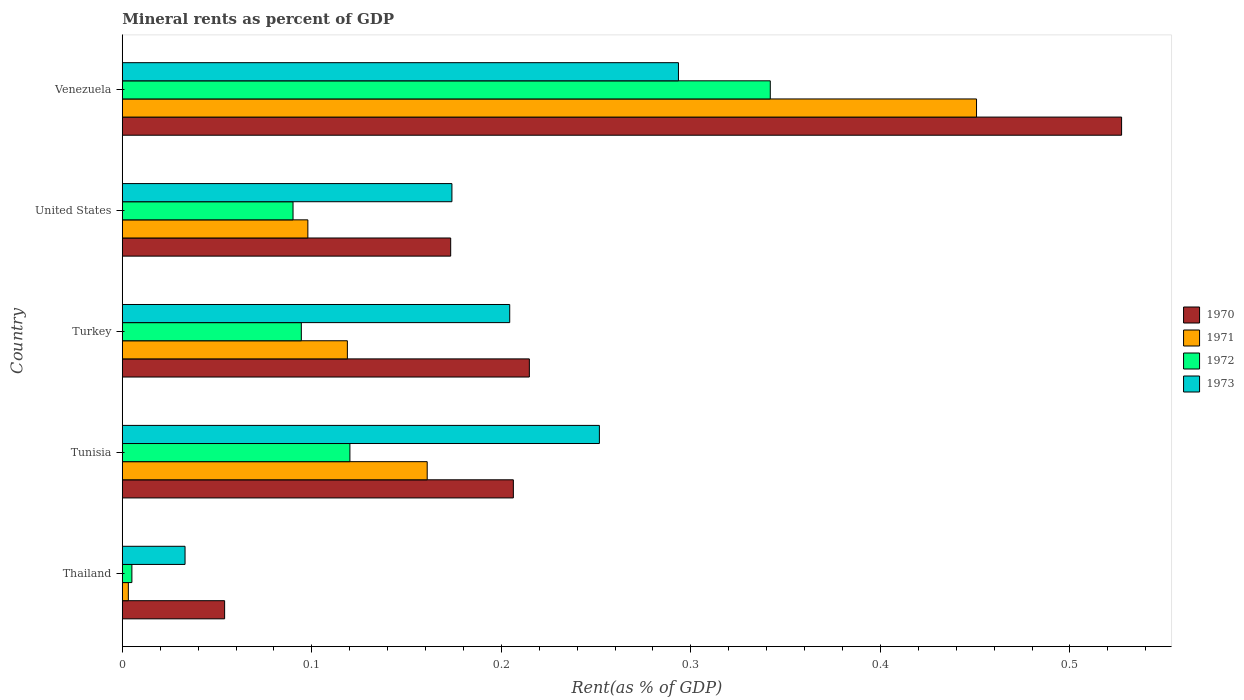How many different coloured bars are there?
Your response must be concise. 4. How many groups of bars are there?
Offer a very short reply. 5. Are the number of bars on each tick of the Y-axis equal?
Make the answer very short. Yes. How many bars are there on the 3rd tick from the top?
Your answer should be very brief. 4. How many bars are there on the 1st tick from the bottom?
Give a very brief answer. 4. What is the label of the 5th group of bars from the top?
Provide a short and direct response. Thailand. In how many cases, is the number of bars for a given country not equal to the number of legend labels?
Provide a succinct answer. 0. What is the mineral rent in 1971 in Tunisia?
Provide a short and direct response. 0.16. Across all countries, what is the maximum mineral rent in 1971?
Your answer should be very brief. 0.45. Across all countries, what is the minimum mineral rent in 1972?
Keep it short and to the point. 0.01. In which country was the mineral rent in 1972 maximum?
Offer a terse response. Venezuela. In which country was the mineral rent in 1972 minimum?
Offer a very short reply. Thailand. What is the total mineral rent in 1972 in the graph?
Keep it short and to the point. 0.65. What is the difference between the mineral rent in 1971 in Turkey and that in Venezuela?
Ensure brevity in your answer.  -0.33. What is the difference between the mineral rent in 1973 in Venezuela and the mineral rent in 1970 in Turkey?
Your answer should be very brief. 0.08. What is the average mineral rent in 1970 per country?
Keep it short and to the point. 0.24. What is the difference between the mineral rent in 1973 and mineral rent in 1970 in Thailand?
Give a very brief answer. -0.02. What is the ratio of the mineral rent in 1971 in United States to that in Venezuela?
Give a very brief answer. 0.22. Is the mineral rent in 1970 in United States less than that in Venezuela?
Provide a short and direct response. Yes. What is the difference between the highest and the second highest mineral rent in 1971?
Give a very brief answer. 0.29. What is the difference between the highest and the lowest mineral rent in 1971?
Make the answer very short. 0.45. In how many countries, is the mineral rent in 1970 greater than the average mineral rent in 1970 taken over all countries?
Your answer should be very brief. 1. What does the 4th bar from the bottom in Tunisia represents?
Make the answer very short. 1973. How many bars are there?
Offer a terse response. 20. How many countries are there in the graph?
Keep it short and to the point. 5. What is the difference between two consecutive major ticks on the X-axis?
Ensure brevity in your answer.  0.1. Does the graph contain any zero values?
Ensure brevity in your answer.  No. How many legend labels are there?
Your response must be concise. 4. How are the legend labels stacked?
Your answer should be compact. Vertical. What is the title of the graph?
Offer a very short reply. Mineral rents as percent of GDP. What is the label or title of the X-axis?
Make the answer very short. Rent(as % of GDP). What is the label or title of the Y-axis?
Keep it short and to the point. Country. What is the Rent(as % of GDP) in 1970 in Thailand?
Your answer should be very brief. 0.05. What is the Rent(as % of GDP) of 1971 in Thailand?
Your response must be concise. 0. What is the Rent(as % of GDP) of 1972 in Thailand?
Your answer should be very brief. 0.01. What is the Rent(as % of GDP) in 1973 in Thailand?
Your answer should be compact. 0.03. What is the Rent(as % of GDP) of 1970 in Tunisia?
Ensure brevity in your answer.  0.21. What is the Rent(as % of GDP) of 1971 in Tunisia?
Offer a very short reply. 0.16. What is the Rent(as % of GDP) in 1972 in Tunisia?
Keep it short and to the point. 0.12. What is the Rent(as % of GDP) of 1973 in Tunisia?
Your answer should be very brief. 0.25. What is the Rent(as % of GDP) of 1970 in Turkey?
Your response must be concise. 0.21. What is the Rent(as % of GDP) of 1971 in Turkey?
Make the answer very short. 0.12. What is the Rent(as % of GDP) in 1972 in Turkey?
Keep it short and to the point. 0.09. What is the Rent(as % of GDP) in 1973 in Turkey?
Your answer should be very brief. 0.2. What is the Rent(as % of GDP) in 1970 in United States?
Ensure brevity in your answer.  0.17. What is the Rent(as % of GDP) in 1971 in United States?
Make the answer very short. 0.1. What is the Rent(as % of GDP) of 1972 in United States?
Your answer should be very brief. 0.09. What is the Rent(as % of GDP) in 1973 in United States?
Your answer should be very brief. 0.17. What is the Rent(as % of GDP) in 1970 in Venezuela?
Ensure brevity in your answer.  0.53. What is the Rent(as % of GDP) of 1971 in Venezuela?
Your response must be concise. 0.45. What is the Rent(as % of GDP) in 1972 in Venezuela?
Your answer should be very brief. 0.34. What is the Rent(as % of GDP) of 1973 in Venezuela?
Provide a short and direct response. 0.29. Across all countries, what is the maximum Rent(as % of GDP) in 1970?
Ensure brevity in your answer.  0.53. Across all countries, what is the maximum Rent(as % of GDP) of 1971?
Your answer should be very brief. 0.45. Across all countries, what is the maximum Rent(as % of GDP) of 1972?
Provide a succinct answer. 0.34. Across all countries, what is the maximum Rent(as % of GDP) in 1973?
Provide a short and direct response. 0.29. Across all countries, what is the minimum Rent(as % of GDP) in 1970?
Ensure brevity in your answer.  0.05. Across all countries, what is the minimum Rent(as % of GDP) in 1971?
Give a very brief answer. 0. Across all countries, what is the minimum Rent(as % of GDP) in 1972?
Provide a short and direct response. 0.01. Across all countries, what is the minimum Rent(as % of GDP) of 1973?
Make the answer very short. 0.03. What is the total Rent(as % of GDP) in 1970 in the graph?
Your response must be concise. 1.18. What is the total Rent(as % of GDP) of 1971 in the graph?
Your response must be concise. 0.83. What is the total Rent(as % of GDP) in 1972 in the graph?
Your answer should be compact. 0.65. What is the total Rent(as % of GDP) in 1973 in the graph?
Provide a short and direct response. 0.96. What is the difference between the Rent(as % of GDP) of 1970 in Thailand and that in Tunisia?
Ensure brevity in your answer.  -0.15. What is the difference between the Rent(as % of GDP) in 1971 in Thailand and that in Tunisia?
Your response must be concise. -0.16. What is the difference between the Rent(as % of GDP) of 1972 in Thailand and that in Tunisia?
Keep it short and to the point. -0.12. What is the difference between the Rent(as % of GDP) of 1973 in Thailand and that in Tunisia?
Make the answer very short. -0.22. What is the difference between the Rent(as % of GDP) in 1970 in Thailand and that in Turkey?
Your response must be concise. -0.16. What is the difference between the Rent(as % of GDP) of 1971 in Thailand and that in Turkey?
Your response must be concise. -0.12. What is the difference between the Rent(as % of GDP) in 1972 in Thailand and that in Turkey?
Provide a short and direct response. -0.09. What is the difference between the Rent(as % of GDP) in 1973 in Thailand and that in Turkey?
Make the answer very short. -0.17. What is the difference between the Rent(as % of GDP) in 1970 in Thailand and that in United States?
Provide a short and direct response. -0.12. What is the difference between the Rent(as % of GDP) of 1971 in Thailand and that in United States?
Make the answer very short. -0.09. What is the difference between the Rent(as % of GDP) in 1972 in Thailand and that in United States?
Keep it short and to the point. -0.09. What is the difference between the Rent(as % of GDP) in 1973 in Thailand and that in United States?
Your response must be concise. -0.14. What is the difference between the Rent(as % of GDP) in 1970 in Thailand and that in Venezuela?
Make the answer very short. -0.47. What is the difference between the Rent(as % of GDP) in 1971 in Thailand and that in Venezuela?
Offer a terse response. -0.45. What is the difference between the Rent(as % of GDP) in 1972 in Thailand and that in Venezuela?
Your response must be concise. -0.34. What is the difference between the Rent(as % of GDP) in 1973 in Thailand and that in Venezuela?
Keep it short and to the point. -0.26. What is the difference between the Rent(as % of GDP) in 1970 in Tunisia and that in Turkey?
Offer a terse response. -0.01. What is the difference between the Rent(as % of GDP) in 1971 in Tunisia and that in Turkey?
Offer a very short reply. 0.04. What is the difference between the Rent(as % of GDP) in 1972 in Tunisia and that in Turkey?
Give a very brief answer. 0.03. What is the difference between the Rent(as % of GDP) in 1973 in Tunisia and that in Turkey?
Provide a short and direct response. 0.05. What is the difference between the Rent(as % of GDP) in 1970 in Tunisia and that in United States?
Your response must be concise. 0.03. What is the difference between the Rent(as % of GDP) in 1971 in Tunisia and that in United States?
Ensure brevity in your answer.  0.06. What is the difference between the Rent(as % of GDP) in 1973 in Tunisia and that in United States?
Provide a short and direct response. 0.08. What is the difference between the Rent(as % of GDP) in 1970 in Tunisia and that in Venezuela?
Keep it short and to the point. -0.32. What is the difference between the Rent(as % of GDP) of 1971 in Tunisia and that in Venezuela?
Make the answer very short. -0.29. What is the difference between the Rent(as % of GDP) of 1972 in Tunisia and that in Venezuela?
Your answer should be compact. -0.22. What is the difference between the Rent(as % of GDP) in 1973 in Tunisia and that in Venezuela?
Your answer should be compact. -0.04. What is the difference between the Rent(as % of GDP) in 1970 in Turkey and that in United States?
Provide a succinct answer. 0.04. What is the difference between the Rent(as % of GDP) of 1971 in Turkey and that in United States?
Provide a short and direct response. 0.02. What is the difference between the Rent(as % of GDP) in 1972 in Turkey and that in United States?
Offer a very short reply. 0. What is the difference between the Rent(as % of GDP) of 1973 in Turkey and that in United States?
Ensure brevity in your answer.  0.03. What is the difference between the Rent(as % of GDP) in 1970 in Turkey and that in Venezuela?
Your response must be concise. -0.31. What is the difference between the Rent(as % of GDP) in 1971 in Turkey and that in Venezuela?
Ensure brevity in your answer.  -0.33. What is the difference between the Rent(as % of GDP) of 1972 in Turkey and that in Venezuela?
Your response must be concise. -0.25. What is the difference between the Rent(as % of GDP) in 1973 in Turkey and that in Venezuela?
Provide a succinct answer. -0.09. What is the difference between the Rent(as % of GDP) of 1970 in United States and that in Venezuela?
Provide a short and direct response. -0.35. What is the difference between the Rent(as % of GDP) in 1971 in United States and that in Venezuela?
Make the answer very short. -0.35. What is the difference between the Rent(as % of GDP) of 1972 in United States and that in Venezuela?
Give a very brief answer. -0.25. What is the difference between the Rent(as % of GDP) of 1973 in United States and that in Venezuela?
Keep it short and to the point. -0.12. What is the difference between the Rent(as % of GDP) in 1970 in Thailand and the Rent(as % of GDP) in 1971 in Tunisia?
Offer a terse response. -0.11. What is the difference between the Rent(as % of GDP) of 1970 in Thailand and the Rent(as % of GDP) of 1972 in Tunisia?
Provide a short and direct response. -0.07. What is the difference between the Rent(as % of GDP) in 1970 in Thailand and the Rent(as % of GDP) in 1973 in Tunisia?
Your answer should be compact. -0.2. What is the difference between the Rent(as % of GDP) in 1971 in Thailand and the Rent(as % of GDP) in 1972 in Tunisia?
Your response must be concise. -0.12. What is the difference between the Rent(as % of GDP) in 1971 in Thailand and the Rent(as % of GDP) in 1973 in Tunisia?
Offer a terse response. -0.25. What is the difference between the Rent(as % of GDP) of 1972 in Thailand and the Rent(as % of GDP) of 1973 in Tunisia?
Provide a succinct answer. -0.25. What is the difference between the Rent(as % of GDP) of 1970 in Thailand and the Rent(as % of GDP) of 1971 in Turkey?
Ensure brevity in your answer.  -0.06. What is the difference between the Rent(as % of GDP) in 1970 in Thailand and the Rent(as % of GDP) in 1972 in Turkey?
Your response must be concise. -0.04. What is the difference between the Rent(as % of GDP) of 1970 in Thailand and the Rent(as % of GDP) of 1973 in Turkey?
Your response must be concise. -0.15. What is the difference between the Rent(as % of GDP) of 1971 in Thailand and the Rent(as % of GDP) of 1972 in Turkey?
Provide a short and direct response. -0.09. What is the difference between the Rent(as % of GDP) in 1971 in Thailand and the Rent(as % of GDP) in 1973 in Turkey?
Offer a terse response. -0.2. What is the difference between the Rent(as % of GDP) in 1972 in Thailand and the Rent(as % of GDP) in 1973 in Turkey?
Your answer should be compact. -0.2. What is the difference between the Rent(as % of GDP) of 1970 in Thailand and the Rent(as % of GDP) of 1971 in United States?
Ensure brevity in your answer.  -0.04. What is the difference between the Rent(as % of GDP) in 1970 in Thailand and the Rent(as % of GDP) in 1972 in United States?
Provide a short and direct response. -0.04. What is the difference between the Rent(as % of GDP) in 1970 in Thailand and the Rent(as % of GDP) in 1973 in United States?
Your answer should be very brief. -0.12. What is the difference between the Rent(as % of GDP) in 1971 in Thailand and the Rent(as % of GDP) in 1972 in United States?
Make the answer very short. -0.09. What is the difference between the Rent(as % of GDP) in 1971 in Thailand and the Rent(as % of GDP) in 1973 in United States?
Keep it short and to the point. -0.17. What is the difference between the Rent(as % of GDP) of 1972 in Thailand and the Rent(as % of GDP) of 1973 in United States?
Your answer should be compact. -0.17. What is the difference between the Rent(as % of GDP) of 1970 in Thailand and the Rent(as % of GDP) of 1971 in Venezuela?
Ensure brevity in your answer.  -0.4. What is the difference between the Rent(as % of GDP) of 1970 in Thailand and the Rent(as % of GDP) of 1972 in Venezuela?
Your answer should be compact. -0.29. What is the difference between the Rent(as % of GDP) in 1970 in Thailand and the Rent(as % of GDP) in 1973 in Venezuela?
Keep it short and to the point. -0.24. What is the difference between the Rent(as % of GDP) of 1971 in Thailand and the Rent(as % of GDP) of 1972 in Venezuela?
Provide a short and direct response. -0.34. What is the difference between the Rent(as % of GDP) in 1971 in Thailand and the Rent(as % of GDP) in 1973 in Venezuela?
Give a very brief answer. -0.29. What is the difference between the Rent(as % of GDP) of 1972 in Thailand and the Rent(as % of GDP) of 1973 in Venezuela?
Ensure brevity in your answer.  -0.29. What is the difference between the Rent(as % of GDP) in 1970 in Tunisia and the Rent(as % of GDP) in 1971 in Turkey?
Give a very brief answer. 0.09. What is the difference between the Rent(as % of GDP) in 1970 in Tunisia and the Rent(as % of GDP) in 1972 in Turkey?
Give a very brief answer. 0.11. What is the difference between the Rent(as % of GDP) in 1970 in Tunisia and the Rent(as % of GDP) in 1973 in Turkey?
Provide a short and direct response. 0. What is the difference between the Rent(as % of GDP) in 1971 in Tunisia and the Rent(as % of GDP) in 1972 in Turkey?
Give a very brief answer. 0.07. What is the difference between the Rent(as % of GDP) of 1971 in Tunisia and the Rent(as % of GDP) of 1973 in Turkey?
Offer a very short reply. -0.04. What is the difference between the Rent(as % of GDP) in 1972 in Tunisia and the Rent(as % of GDP) in 1973 in Turkey?
Ensure brevity in your answer.  -0.08. What is the difference between the Rent(as % of GDP) of 1970 in Tunisia and the Rent(as % of GDP) of 1971 in United States?
Offer a very short reply. 0.11. What is the difference between the Rent(as % of GDP) in 1970 in Tunisia and the Rent(as % of GDP) in 1972 in United States?
Give a very brief answer. 0.12. What is the difference between the Rent(as % of GDP) of 1970 in Tunisia and the Rent(as % of GDP) of 1973 in United States?
Give a very brief answer. 0.03. What is the difference between the Rent(as % of GDP) of 1971 in Tunisia and the Rent(as % of GDP) of 1972 in United States?
Your answer should be very brief. 0.07. What is the difference between the Rent(as % of GDP) in 1971 in Tunisia and the Rent(as % of GDP) in 1973 in United States?
Provide a short and direct response. -0.01. What is the difference between the Rent(as % of GDP) of 1972 in Tunisia and the Rent(as % of GDP) of 1973 in United States?
Offer a terse response. -0.05. What is the difference between the Rent(as % of GDP) in 1970 in Tunisia and the Rent(as % of GDP) in 1971 in Venezuela?
Give a very brief answer. -0.24. What is the difference between the Rent(as % of GDP) in 1970 in Tunisia and the Rent(as % of GDP) in 1972 in Venezuela?
Your answer should be very brief. -0.14. What is the difference between the Rent(as % of GDP) in 1970 in Tunisia and the Rent(as % of GDP) in 1973 in Venezuela?
Offer a very short reply. -0.09. What is the difference between the Rent(as % of GDP) in 1971 in Tunisia and the Rent(as % of GDP) in 1972 in Venezuela?
Offer a terse response. -0.18. What is the difference between the Rent(as % of GDP) of 1971 in Tunisia and the Rent(as % of GDP) of 1973 in Venezuela?
Provide a succinct answer. -0.13. What is the difference between the Rent(as % of GDP) of 1972 in Tunisia and the Rent(as % of GDP) of 1973 in Venezuela?
Provide a short and direct response. -0.17. What is the difference between the Rent(as % of GDP) of 1970 in Turkey and the Rent(as % of GDP) of 1971 in United States?
Offer a very short reply. 0.12. What is the difference between the Rent(as % of GDP) of 1970 in Turkey and the Rent(as % of GDP) of 1972 in United States?
Provide a short and direct response. 0.12. What is the difference between the Rent(as % of GDP) in 1970 in Turkey and the Rent(as % of GDP) in 1973 in United States?
Your answer should be compact. 0.04. What is the difference between the Rent(as % of GDP) in 1971 in Turkey and the Rent(as % of GDP) in 1972 in United States?
Ensure brevity in your answer.  0.03. What is the difference between the Rent(as % of GDP) in 1971 in Turkey and the Rent(as % of GDP) in 1973 in United States?
Ensure brevity in your answer.  -0.06. What is the difference between the Rent(as % of GDP) of 1972 in Turkey and the Rent(as % of GDP) of 1973 in United States?
Provide a short and direct response. -0.08. What is the difference between the Rent(as % of GDP) in 1970 in Turkey and the Rent(as % of GDP) in 1971 in Venezuela?
Provide a succinct answer. -0.24. What is the difference between the Rent(as % of GDP) of 1970 in Turkey and the Rent(as % of GDP) of 1972 in Venezuela?
Your answer should be compact. -0.13. What is the difference between the Rent(as % of GDP) in 1970 in Turkey and the Rent(as % of GDP) in 1973 in Venezuela?
Offer a terse response. -0.08. What is the difference between the Rent(as % of GDP) in 1971 in Turkey and the Rent(as % of GDP) in 1972 in Venezuela?
Provide a succinct answer. -0.22. What is the difference between the Rent(as % of GDP) in 1971 in Turkey and the Rent(as % of GDP) in 1973 in Venezuela?
Keep it short and to the point. -0.17. What is the difference between the Rent(as % of GDP) of 1972 in Turkey and the Rent(as % of GDP) of 1973 in Venezuela?
Ensure brevity in your answer.  -0.2. What is the difference between the Rent(as % of GDP) of 1970 in United States and the Rent(as % of GDP) of 1971 in Venezuela?
Keep it short and to the point. -0.28. What is the difference between the Rent(as % of GDP) of 1970 in United States and the Rent(as % of GDP) of 1972 in Venezuela?
Offer a very short reply. -0.17. What is the difference between the Rent(as % of GDP) of 1970 in United States and the Rent(as % of GDP) of 1973 in Venezuela?
Ensure brevity in your answer.  -0.12. What is the difference between the Rent(as % of GDP) in 1971 in United States and the Rent(as % of GDP) in 1972 in Venezuela?
Offer a very short reply. -0.24. What is the difference between the Rent(as % of GDP) of 1971 in United States and the Rent(as % of GDP) of 1973 in Venezuela?
Your response must be concise. -0.2. What is the difference between the Rent(as % of GDP) in 1972 in United States and the Rent(as % of GDP) in 1973 in Venezuela?
Provide a succinct answer. -0.2. What is the average Rent(as % of GDP) of 1970 per country?
Provide a short and direct response. 0.24. What is the average Rent(as % of GDP) in 1971 per country?
Keep it short and to the point. 0.17. What is the average Rent(as % of GDP) in 1972 per country?
Provide a succinct answer. 0.13. What is the average Rent(as % of GDP) in 1973 per country?
Offer a very short reply. 0.19. What is the difference between the Rent(as % of GDP) of 1970 and Rent(as % of GDP) of 1971 in Thailand?
Offer a very short reply. 0.05. What is the difference between the Rent(as % of GDP) of 1970 and Rent(as % of GDP) of 1972 in Thailand?
Ensure brevity in your answer.  0.05. What is the difference between the Rent(as % of GDP) of 1970 and Rent(as % of GDP) of 1973 in Thailand?
Your response must be concise. 0.02. What is the difference between the Rent(as % of GDP) of 1971 and Rent(as % of GDP) of 1972 in Thailand?
Provide a short and direct response. -0. What is the difference between the Rent(as % of GDP) in 1971 and Rent(as % of GDP) in 1973 in Thailand?
Keep it short and to the point. -0.03. What is the difference between the Rent(as % of GDP) of 1972 and Rent(as % of GDP) of 1973 in Thailand?
Offer a very short reply. -0.03. What is the difference between the Rent(as % of GDP) of 1970 and Rent(as % of GDP) of 1971 in Tunisia?
Make the answer very short. 0.05. What is the difference between the Rent(as % of GDP) in 1970 and Rent(as % of GDP) in 1972 in Tunisia?
Give a very brief answer. 0.09. What is the difference between the Rent(as % of GDP) in 1970 and Rent(as % of GDP) in 1973 in Tunisia?
Give a very brief answer. -0.05. What is the difference between the Rent(as % of GDP) of 1971 and Rent(as % of GDP) of 1972 in Tunisia?
Give a very brief answer. 0.04. What is the difference between the Rent(as % of GDP) in 1971 and Rent(as % of GDP) in 1973 in Tunisia?
Offer a very short reply. -0.09. What is the difference between the Rent(as % of GDP) of 1972 and Rent(as % of GDP) of 1973 in Tunisia?
Provide a succinct answer. -0.13. What is the difference between the Rent(as % of GDP) of 1970 and Rent(as % of GDP) of 1971 in Turkey?
Your answer should be compact. 0.1. What is the difference between the Rent(as % of GDP) in 1970 and Rent(as % of GDP) in 1972 in Turkey?
Your response must be concise. 0.12. What is the difference between the Rent(as % of GDP) of 1970 and Rent(as % of GDP) of 1973 in Turkey?
Offer a terse response. 0.01. What is the difference between the Rent(as % of GDP) of 1971 and Rent(as % of GDP) of 1972 in Turkey?
Provide a short and direct response. 0.02. What is the difference between the Rent(as % of GDP) of 1971 and Rent(as % of GDP) of 1973 in Turkey?
Your response must be concise. -0.09. What is the difference between the Rent(as % of GDP) in 1972 and Rent(as % of GDP) in 1973 in Turkey?
Your answer should be compact. -0.11. What is the difference between the Rent(as % of GDP) of 1970 and Rent(as % of GDP) of 1971 in United States?
Make the answer very short. 0.08. What is the difference between the Rent(as % of GDP) in 1970 and Rent(as % of GDP) in 1972 in United States?
Give a very brief answer. 0.08. What is the difference between the Rent(as % of GDP) of 1970 and Rent(as % of GDP) of 1973 in United States?
Your response must be concise. -0. What is the difference between the Rent(as % of GDP) in 1971 and Rent(as % of GDP) in 1972 in United States?
Give a very brief answer. 0.01. What is the difference between the Rent(as % of GDP) in 1971 and Rent(as % of GDP) in 1973 in United States?
Offer a very short reply. -0.08. What is the difference between the Rent(as % of GDP) of 1972 and Rent(as % of GDP) of 1973 in United States?
Offer a very short reply. -0.08. What is the difference between the Rent(as % of GDP) in 1970 and Rent(as % of GDP) in 1971 in Venezuela?
Ensure brevity in your answer.  0.08. What is the difference between the Rent(as % of GDP) in 1970 and Rent(as % of GDP) in 1972 in Venezuela?
Provide a short and direct response. 0.19. What is the difference between the Rent(as % of GDP) in 1970 and Rent(as % of GDP) in 1973 in Venezuela?
Provide a short and direct response. 0.23. What is the difference between the Rent(as % of GDP) of 1971 and Rent(as % of GDP) of 1972 in Venezuela?
Your response must be concise. 0.11. What is the difference between the Rent(as % of GDP) in 1971 and Rent(as % of GDP) in 1973 in Venezuela?
Offer a terse response. 0.16. What is the difference between the Rent(as % of GDP) of 1972 and Rent(as % of GDP) of 1973 in Venezuela?
Offer a terse response. 0.05. What is the ratio of the Rent(as % of GDP) of 1970 in Thailand to that in Tunisia?
Ensure brevity in your answer.  0.26. What is the ratio of the Rent(as % of GDP) of 1971 in Thailand to that in Tunisia?
Your answer should be very brief. 0.02. What is the ratio of the Rent(as % of GDP) of 1972 in Thailand to that in Tunisia?
Provide a short and direct response. 0.04. What is the ratio of the Rent(as % of GDP) in 1973 in Thailand to that in Tunisia?
Offer a very short reply. 0.13. What is the ratio of the Rent(as % of GDP) in 1970 in Thailand to that in Turkey?
Provide a short and direct response. 0.25. What is the ratio of the Rent(as % of GDP) in 1971 in Thailand to that in Turkey?
Keep it short and to the point. 0.03. What is the ratio of the Rent(as % of GDP) of 1972 in Thailand to that in Turkey?
Keep it short and to the point. 0.05. What is the ratio of the Rent(as % of GDP) in 1973 in Thailand to that in Turkey?
Provide a short and direct response. 0.16. What is the ratio of the Rent(as % of GDP) of 1970 in Thailand to that in United States?
Keep it short and to the point. 0.31. What is the ratio of the Rent(as % of GDP) of 1971 in Thailand to that in United States?
Your answer should be very brief. 0.03. What is the ratio of the Rent(as % of GDP) of 1972 in Thailand to that in United States?
Keep it short and to the point. 0.06. What is the ratio of the Rent(as % of GDP) of 1973 in Thailand to that in United States?
Give a very brief answer. 0.19. What is the ratio of the Rent(as % of GDP) of 1970 in Thailand to that in Venezuela?
Your answer should be very brief. 0.1. What is the ratio of the Rent(as % of GDP) in 1971 in Thailand to that in Venezuela?
Your response must be concise. 0.01. What is the ratio of the Rent(as % of GDP) in 1972 in Thailand to that in Venezuela?
Provide a short and direct response. 0.01. What is the ratio of the Rent(as % of GDP) in 1973 in Thailand to that in Venezuela?
Give a very brief answer. 0.11. What is the ratio of the Rent(as % of GDP) of 1970 in Tunisia to that in Turkey?
Make the answer very short. 0.96. What is the ratio of the Rent(as % of GDP) of 1971 in Tunisia to that in Turkey?
Ensure brevity in your answer.  1.35. What is the ratio of the Rent(as % of GDP) of 1972 in Tunisia to that in Turkey?
Your answer should be very brief. 1.27. What is the ratio of the Rent(as % of GDP) in 1973 in Tunisia to that in Turkey?
Your response must be concise. 1.23. What is the ratio of the Rent(as % of GDP) in 1970 in Tunisia to that in United States?
Your answer should be compact. 1.19. What is the ratio of the Rent(as % of GDP) of 1971 in Tunisia to that in United States?
Offer a terse response. 1.64. What is the ratio of the Rent(as % of GDP) in 1972 in Tunisia to that in United States?
Offer a very short reply. 1.33. What is the ratio of the Rent(as % of GDP) in 1973 in Tunisia to that in United States?
Your answer should be very brief. 1.45. What is the ratio of the Rent(as % of GDP) of 1970 in Tunisia to that in Venezuela?
Provide a short and direct response. 0.39. What is the ratio of the Rent(as % of GDP) of 1971 in Tunisia to that in Venezuela?
Provide a short and direct response. 0.36. What is the ratio of the Rent(as % of GDP) of 1972 in Tunisia to that in Venezuela?
Keep it short and to the point. 0.35. What is the ratio of the Rent(as % of GDP) of 1973 in Tunisia to that in Venezuela?
Give a very brief answer. 0.86. What is the ratio of the Rent(as % of GDP) of 1970 in Turkey to that in United States?
Ensure brevity in your answer.  1.24. What is the ratio of the Rent(as % of GDP) in 1971 in Turkey to that in United States?
Ensure brevity in your answer.  1.21. What is the ratio of the Rent(as % of GDP) in 1972 in Turkey to that in United States?
Offer a terse response. 1.05. What is the ratio of the Rent(as % of GDP) of 1973 in Turkey to that in United States?
Your answer should be very brief. 1.18. What is the ratio of the Rent(as % of GDP) in 1970 in Turkey to that in Venezuela?
Give a very brief answer. 0.41. What is the ratio of the Rent(as % of GDP) in 1971 in Turkey to that in Venezuela?
Provide a succinct answer. 0.26. What is the ratio of the Rent(as % of GDP) of 1972 in Turkey to that in Venezuela?
Your answer should be very brief. 0.28. What is the ratio of the Rent(as % of GDP) of 1973 in Turkey to that in Venezuela?
Your answer should be compact. 0.7. What is the ratio of the Rent(as % of GDP) in 1970 in United States to that in Venezuela?
Give a very brief answer. 0.33. What is the ratio of the Rent(as % of GDP) in 1971 in United States to that in Venezuela?
Your answer should be very brief. 0.22. What is the ratio of the Rent(as % of GDP) in 1972 in United States to that in Venezuela?
Keep it short and to the point. 0.26. What is the ratio of the Rent(as % of GDP) in 1973 in United States to that in Venezuela?
Make the answer very short. 0.59. What is the difference between the highest and the second highest Rent(as % of GDP) of 1970?
Ensure brevity in your answer.  0.31. What is the difference between the highest and the second highest Rent(as % of GDP) of 1971?
Offer a very short reply. 0.29. What is the difference between the highest and the second highest Rent(as % of GDP) in 1972?
Make the answer very short. 0.22. What is the difference between the highest and the second highest Rent(as % of GDP) of 1973?
Offer a very short reply. 0.04. What is the difference between the highest and the lowest Rent(as % of GDP) of 1970?
Provide a short and direct response. 0.47. What is the difference between the highest and the lowest Rent(as % of GDP) of 1971?
Provide a short and direct response. 0.45. What is the difference between the highest and the lowest Rent(as % of GDP) of 1972?
Offer a very short reply. 0.34. What is the difference between the highest and the lowest Rent(as % of GDP) in 1973?
Your answer should be very brief. 0.26. 